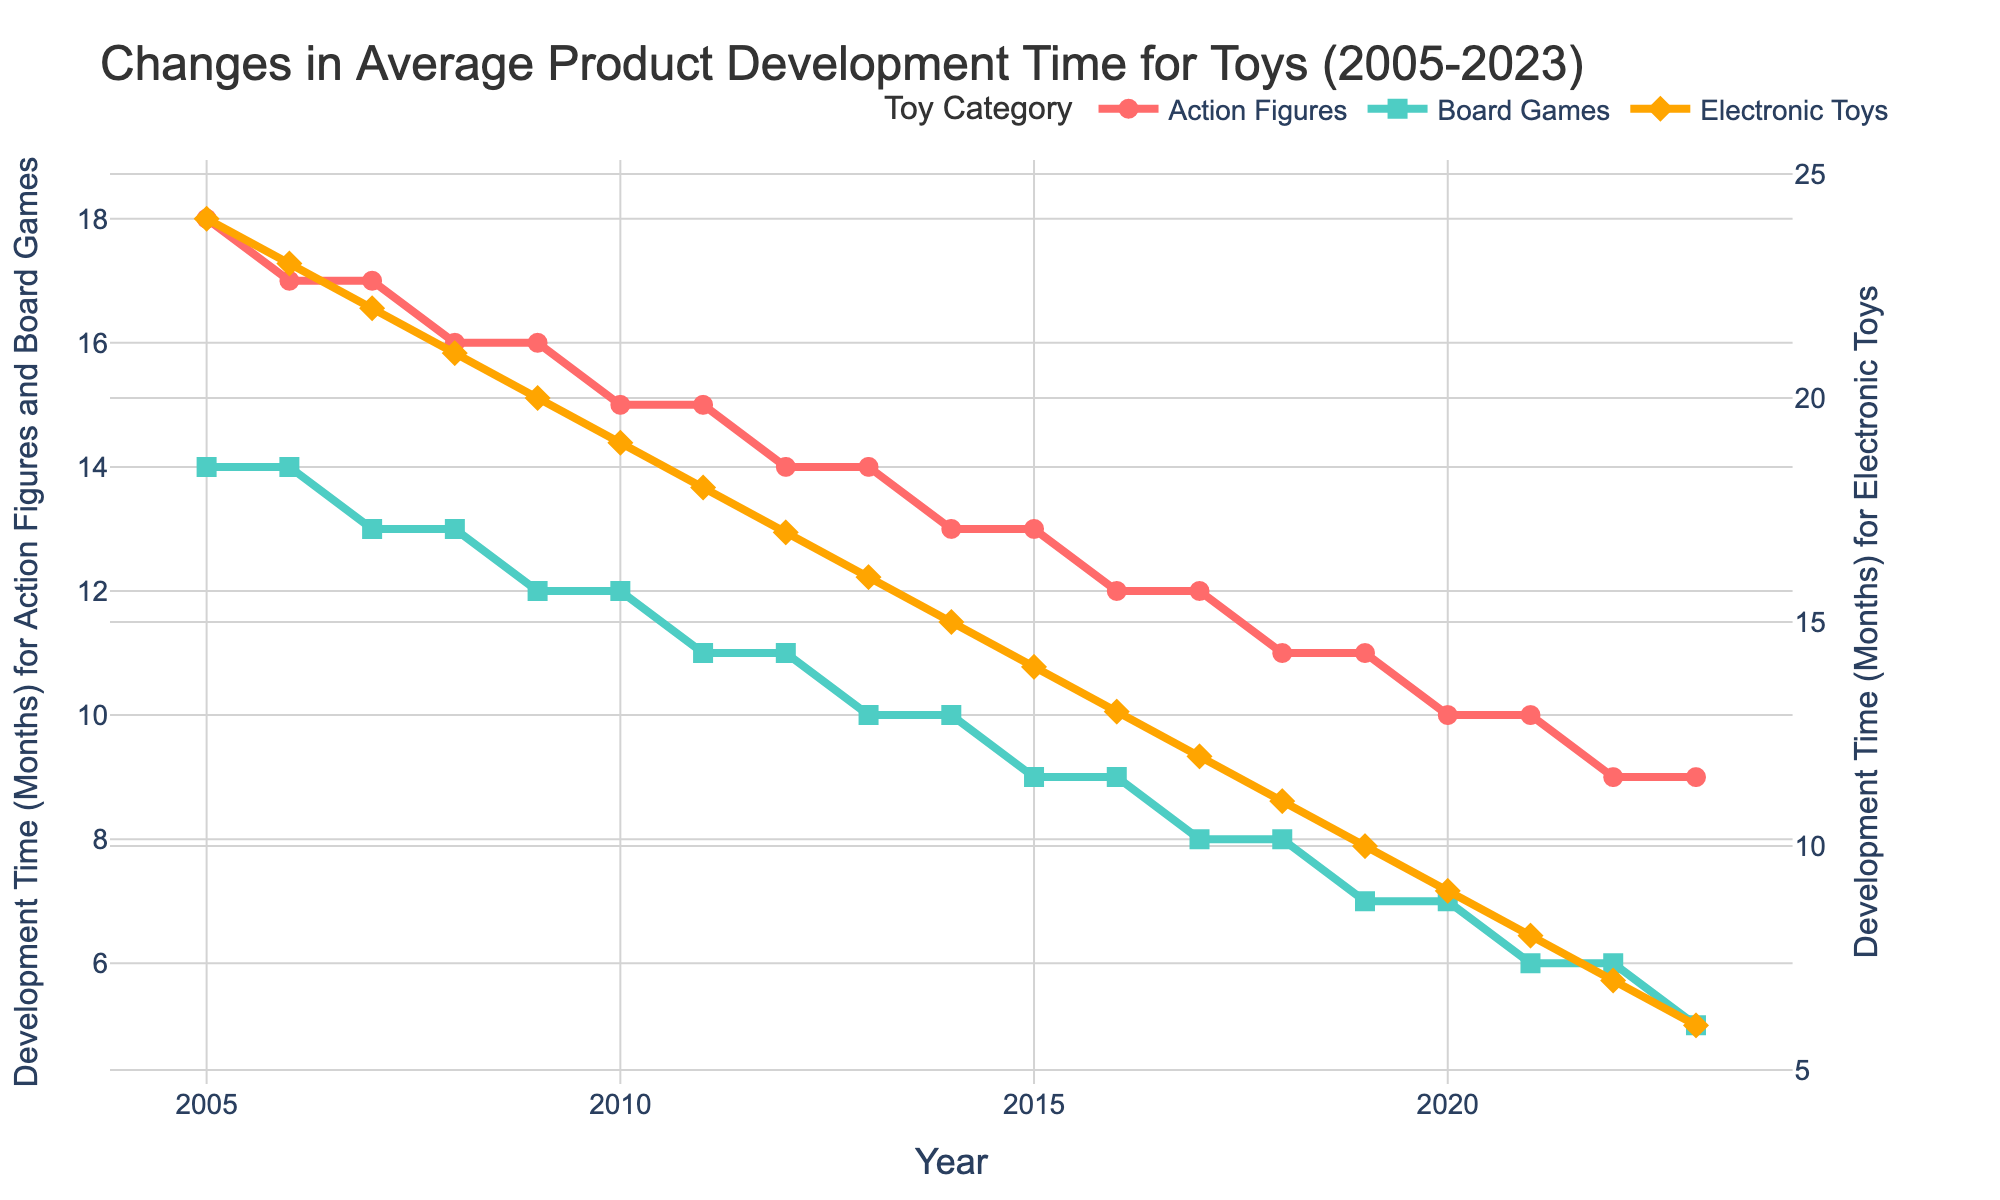How does the development time for Board Games change from 2005 to 2023? To determine the change in development time for Board Games from 2005 to 2023, subtract the value in 2023 (5 months) from the value in 2005 (14 months).
Answer: -9 months Which toy category experienced the largest reduction in development time from 2005 to 2023? To find this, calculate the difference between 2005 and 2023 for all categories: Action Figures: 18-9 = 9 months, Board Games: 14-5 = 9 months, Electronic Toys: 24-6 = 18 months. The largest reduction is for Electronic Toys.
Answer: Electronic Toys In which year did the development time for Action Figures become less than 15 months? Look at the timeline for Action Figures and identify the first year when the development time is below 15 months. This occurs in 2012 when the development time is 14 months.
Answer: 2012 What is the average development time for Electronic Toys over the period 2005-2023? Sum the development times for each year (24+23+22+21+20+19+18+17+16+15+14+13+12+11+10+9+8+7+6) and divide by the number of years (19). Total is 299 months, so average is 299/19.
Answer: 15.74 months Compare the development times of Board Games and Electronic Toys in 2013. Which one was higher and by how much? Refer to the figure, in 2013, the development time for Board Games is 10 months and for Electronic Toys it is 16 months. Electronic Toys development time is higher by 16 - 10.
Answer: 6 months What visual differences do you observe in the trends for each toy category from 2005 to 2023? Observe the plotted lines for each category. Action Figures (red line) and Board Games (green line) both show a steady decline. Electronic Toys (orange line) also declines, but starts higher and ends lower, showing the largest decrease.
Answer: Various trends showing continuous declines During what years did the development time for Action Figures remain constant? Identify the flat segments in the Action Figures line. The development time remains constant at two periods (17 months) from 2006 to 2007, and (16 months) from 2008 to 2009.
Answer: 2006-2007 and 2008-2009 By what percentage did the development time for Board Games decrease from 2005 to 2023? First calculate the absolute change: 14 (2005) to 5 (2023) is a 9-month decrease. To find the percentage change: (9 decrease / 14 original) * 100%.
Answer: 64.29% What can be inferred from the trends of all three toy categories over the years? All three categories show a consistent decrease in development time from 2005 to 2023, indicating improvements in their development processes, with Electronic Toys showing the most significant reduction.
Answer: Improved efficiency 